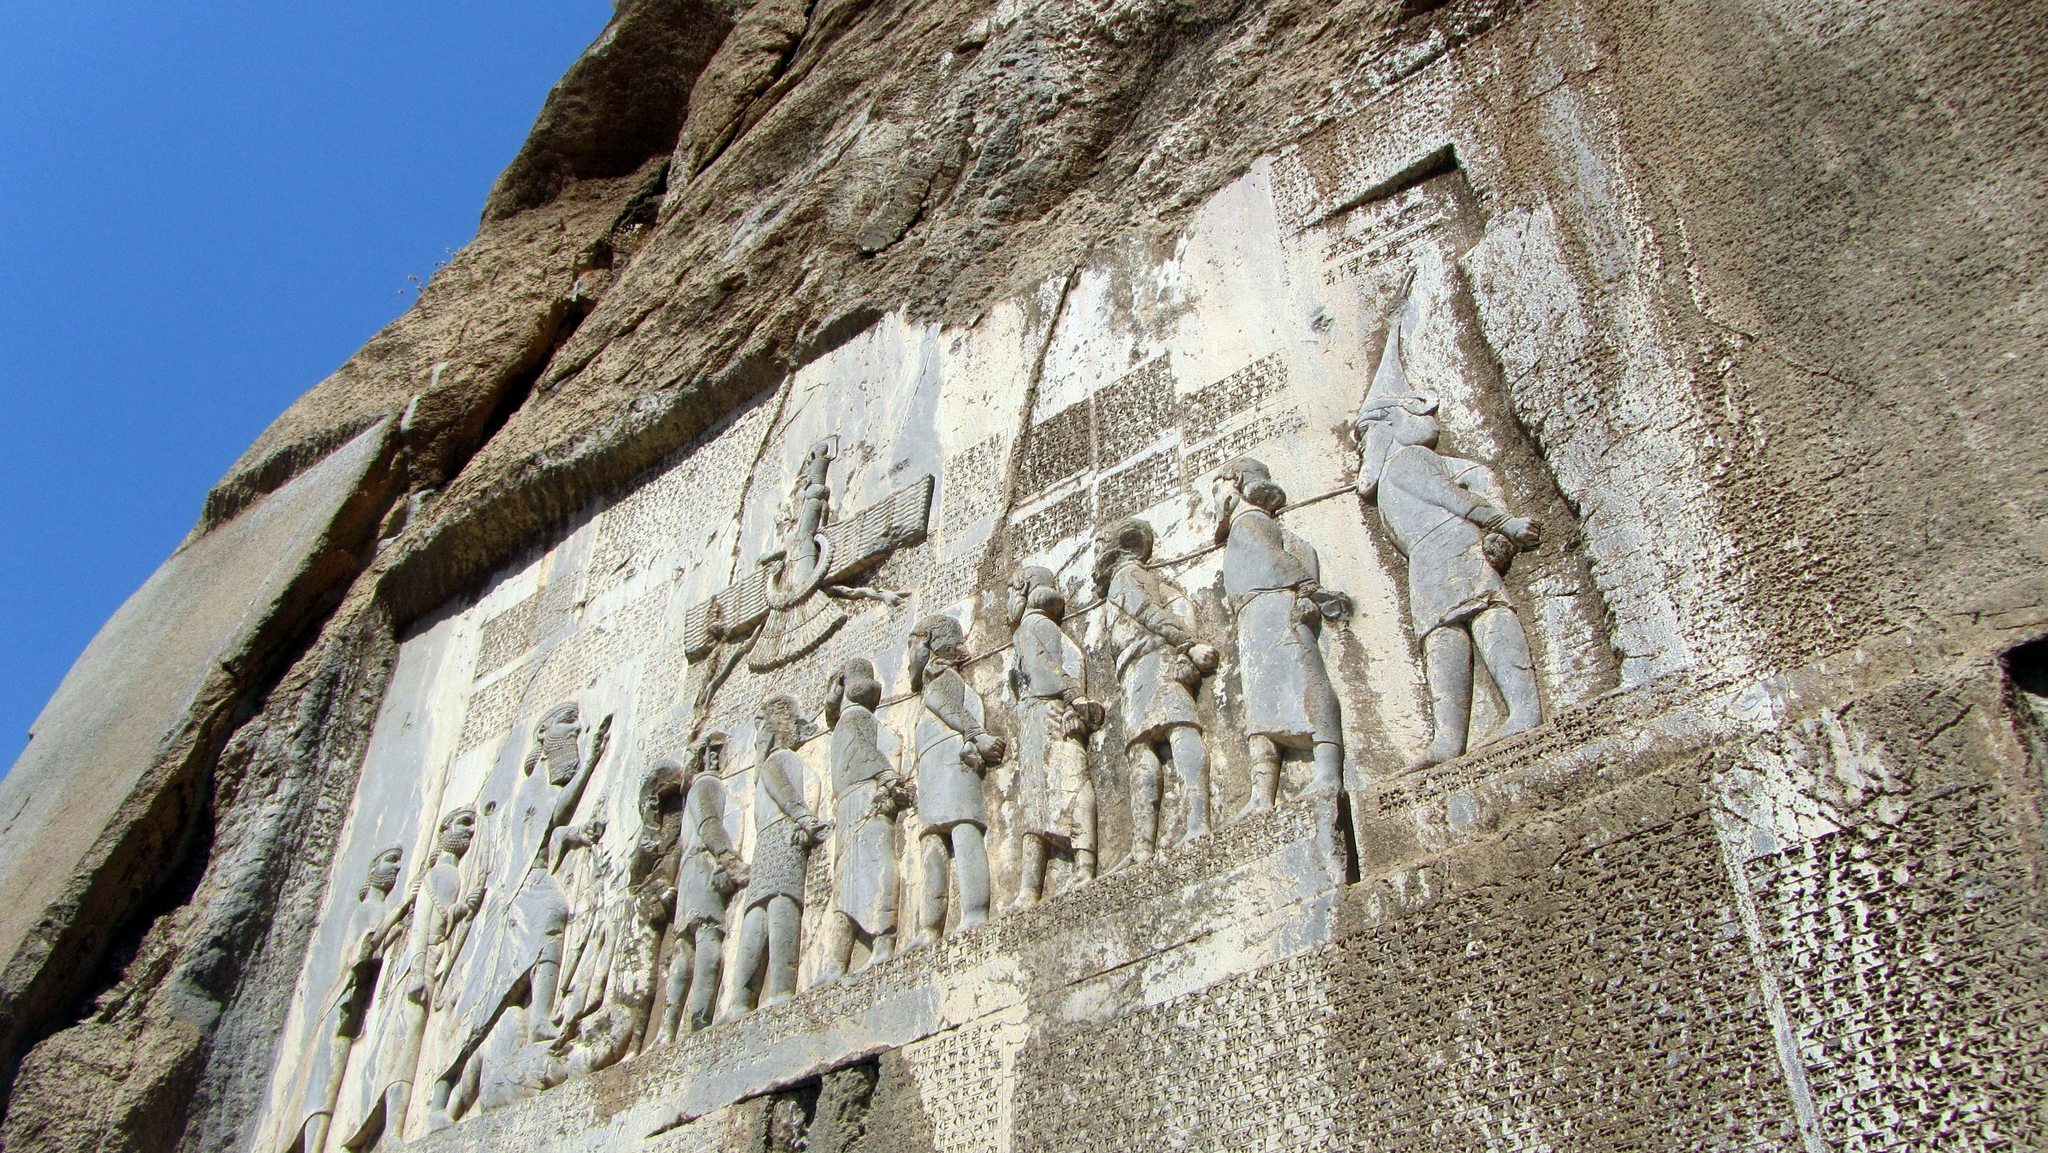What can you tell me about the historical context surrounding this inscription? The Behistun Inscription is crucial for understanding the reign and empire of Darius the Great of Persia near the end of the 6th century BCE. This monumental carving was used to proclaim and legitimize Darius's ascension to the throne after a period of political turmoil that followed the death of Cyrus the Great and the reign of Cambyses. It details Darius’s victories over rival claimants and uprisings, effectively stabilizing his rule and establishing a narrative of divine support and rightful kingship. 